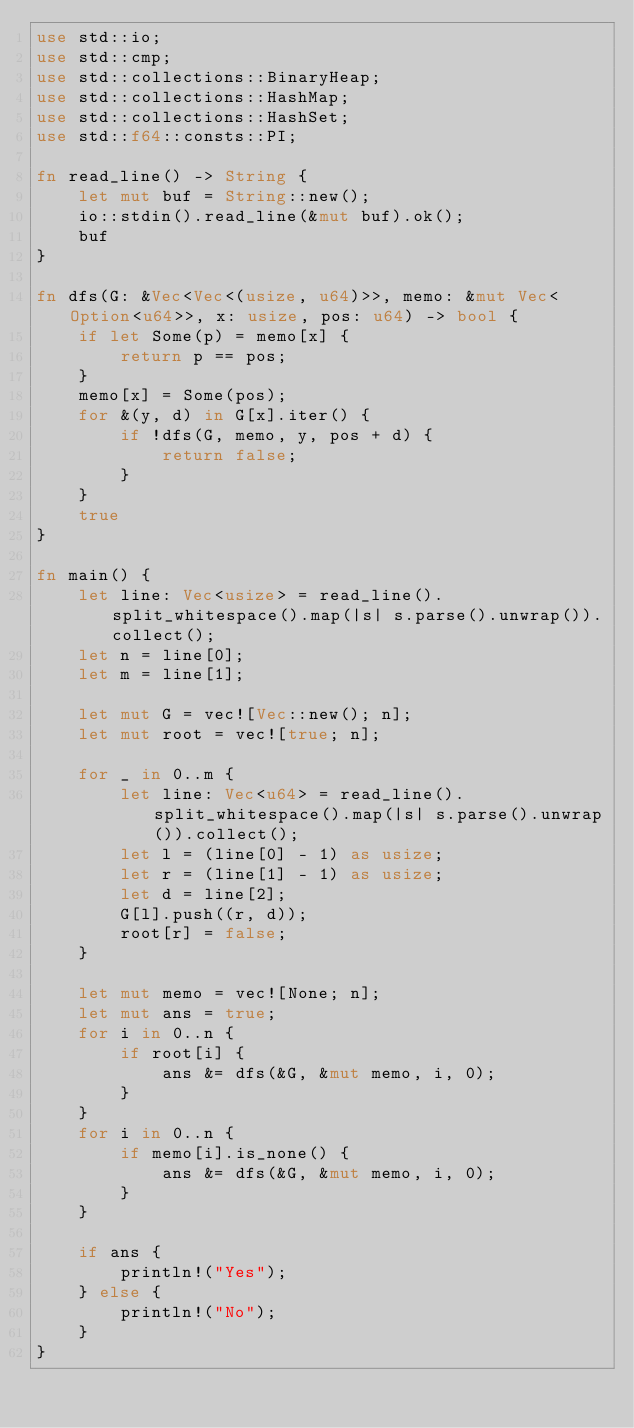Convert code to text. <code><loc_0><loc_0><loc_500><loc_500><_Rust_>use std::io;
use std::cmp;
use std::collections::BinaryHeap;
use std::collections::HashMap;
use std::collections::HashSet;
use std::f64::consts::PI;

fn read_line() -> String {
    let mut buf = String::new();
    io::stdin().read_line(&mut buf).ok();
    buf
}

fn dfs(G: &Vec<Vec<(usize, u64)>>, memo: &mut Vec<Option<u64>>, x: usize, pos: u64) -> bool {
    if let Some(p) = memo[x] {
        return p == pos;
    }
    memo[x] = Some(pos);
    for &(y, d) in G[x].iter() {
        if !dfs(G, memo, y, pos + d) {
            return false;
        }
    }
    true
}

fn main() {
    let line: Vec<usize> = read_line().split_whitespace().map(|s| s.parse().unwrap()).collect();
    let n = line[0];
    let m = line[1];

    let mut G = vec![Vec::new(); n];
    let mut root = vec![true; n];

    for _ in 0..m {
        let line: Vec<u64> = read_line().split_whitespace().map(|s| s.parse().unwrap()).collect();
        let l = (line[0] - 1) as usize;
        let r = (line[1] - 1) as usize;
        let d = line[2];
        G[l].push((r, d));
        root[r] = false;
    }

    let mut memo = vec![None; n];
    let mut ans = true;
    for i in 0..n {
        if root[i] {
            ans &= dfs(&G, &mut memo, i, 0);
        }
    }
    for i in 0..n {
        if memo[i].is_none() {
            ans &= dfs(&G, &mut memo, i, 0);
        }
    }

    if ans {
        println!("Yes");
    } else {
        println!("No");
    }
}
</code> 